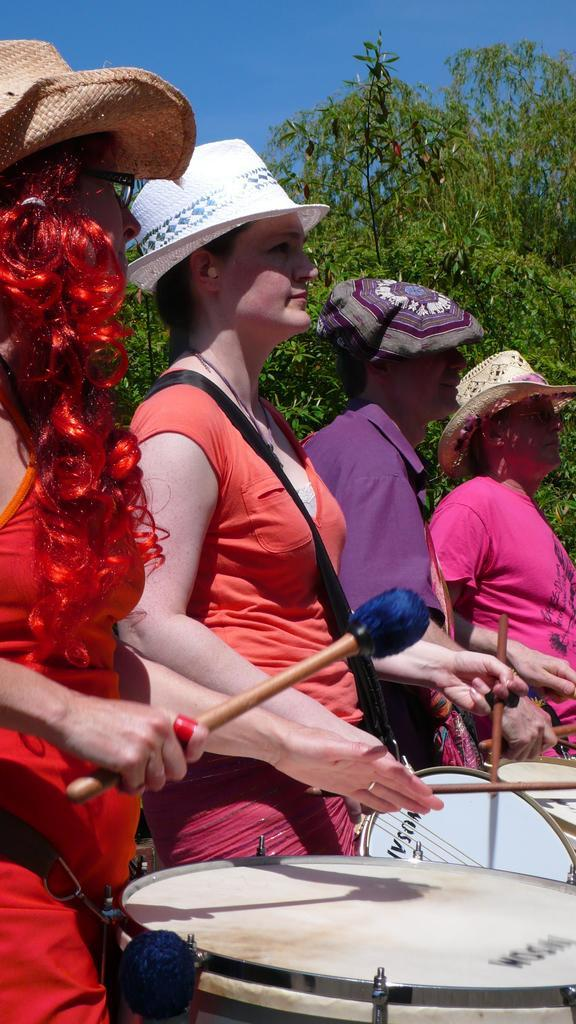What type of scene is depicted in the image? The image is of an outdoor scene. What are the people in the foreground doing? The people are standing and playing drums. What are the people using to play the drums? The people are holding drumsticks. What can be seen in the background of the image? There are trees and the sky visible in the background. How many eggs are being used by the people in the image? There are no eggs present in the image; the people are playing drums with drumsticks. What type of cast is visible on the arm of the person playing the drums? There is no cast visible on any person's arm in the image; the people are playing drums without any visible injuries or medical devices. 